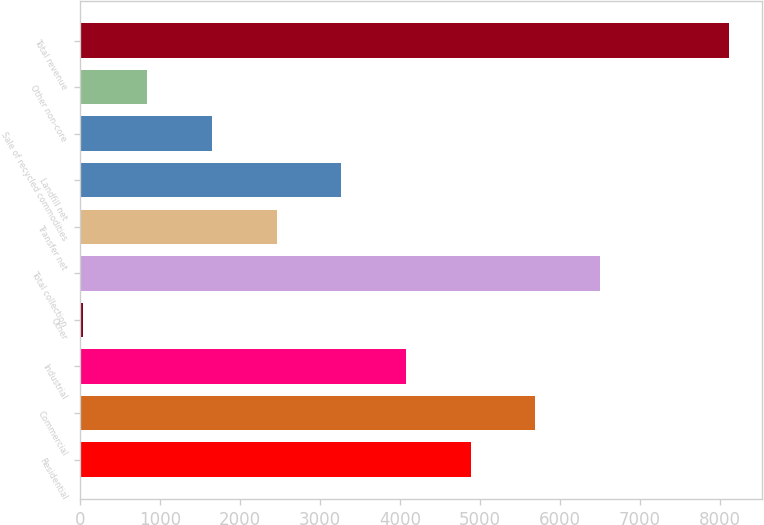<chart> <loc_0><loc_0><loc_500><loc_500><bar_chart><fcel>Residential<fcel>Commercial<fcel>Industrial<fcel>Other<fcel>Total collection<fcel>Transfer net<fcel>Landfill net<fcel>Sale of recycled commodities<fcel>Other non-core<fcel>Total revenue<nl><fcel>4884.34<fcel>5692.83<fcel>4075.85<fcel>33.4<fcel>6501.32<fcel>2458.87<fcel>3267.36<fcel>1650.38<fcel>841.89<fcel>8118.3<nl></chart> 